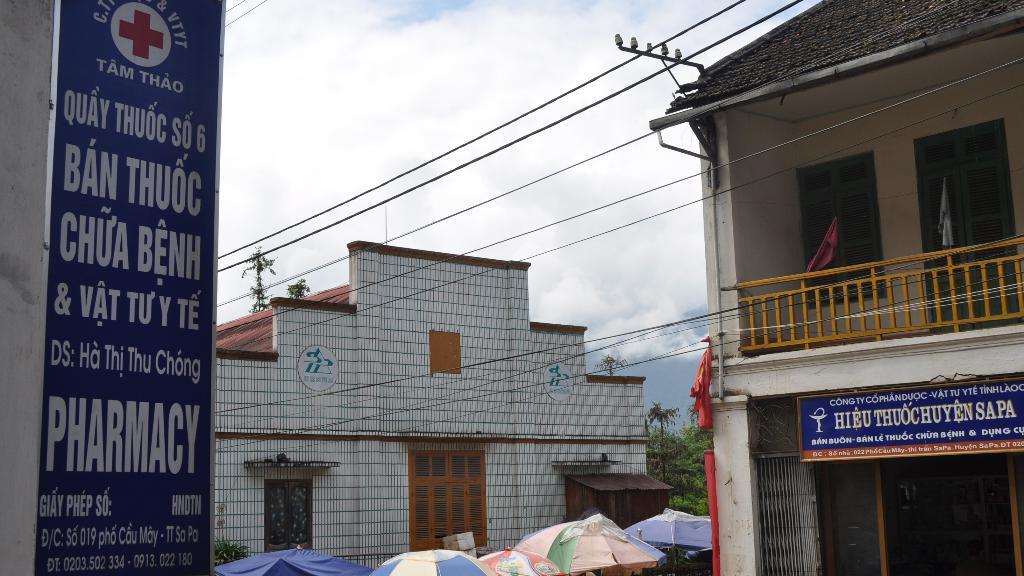Could you give a brief overview of what you see in this image? On the right side, we see a building in white color with a grey color roof. We see the yellow color railing and a board in blue color with some text written on it. We see the flags in white and pink color. At the bottom, we see the umbrella tents in blue, white, green and yellow color. On the left side, we see a board in blue color with some text written on it. In the middle, we see a building in white color with a brown color roof. There are trees in the background. At the top, we see the wires, clouds and the sky. 